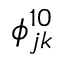Convert formula to latex. <formula><loc_0><loc_0><loc_500><loc_500>\phi _ { j k } ^ { 1 0 }</formula> 